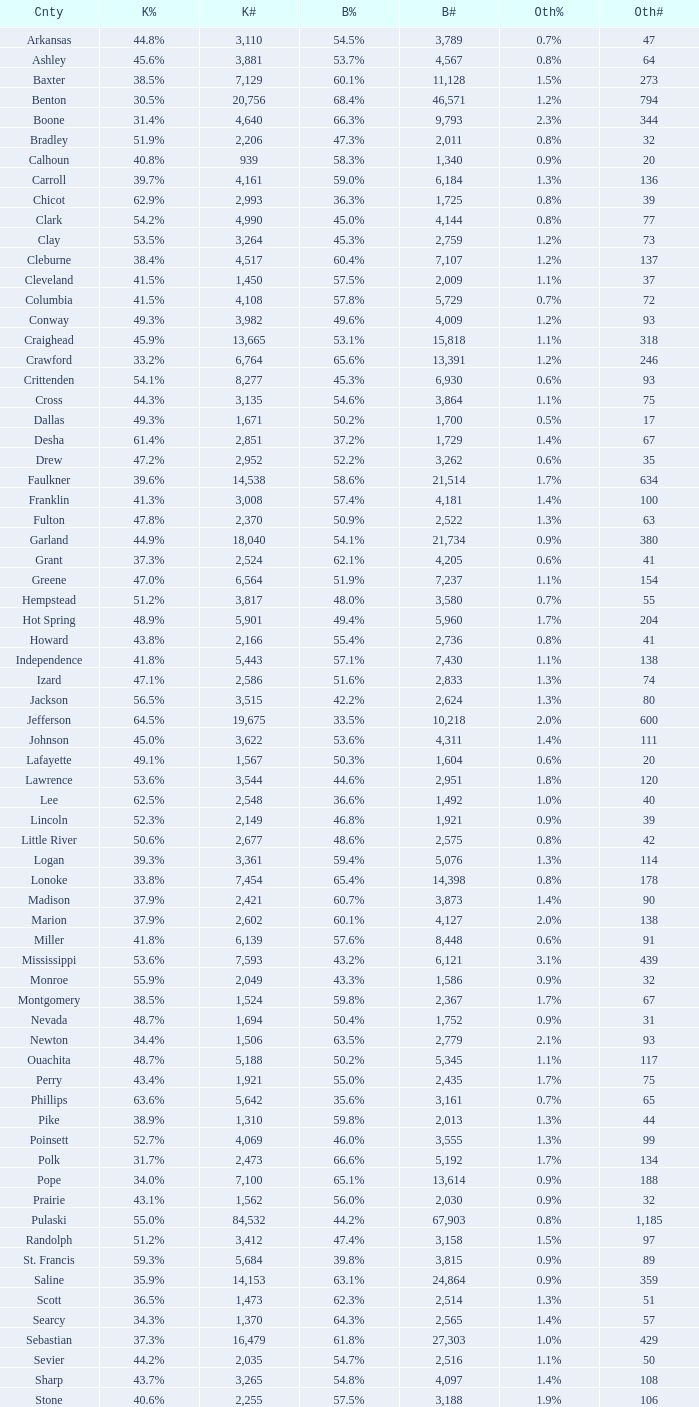What is the lowest Kerry#, when Others# is "106", and when Bush# is less than 3,188? None. 